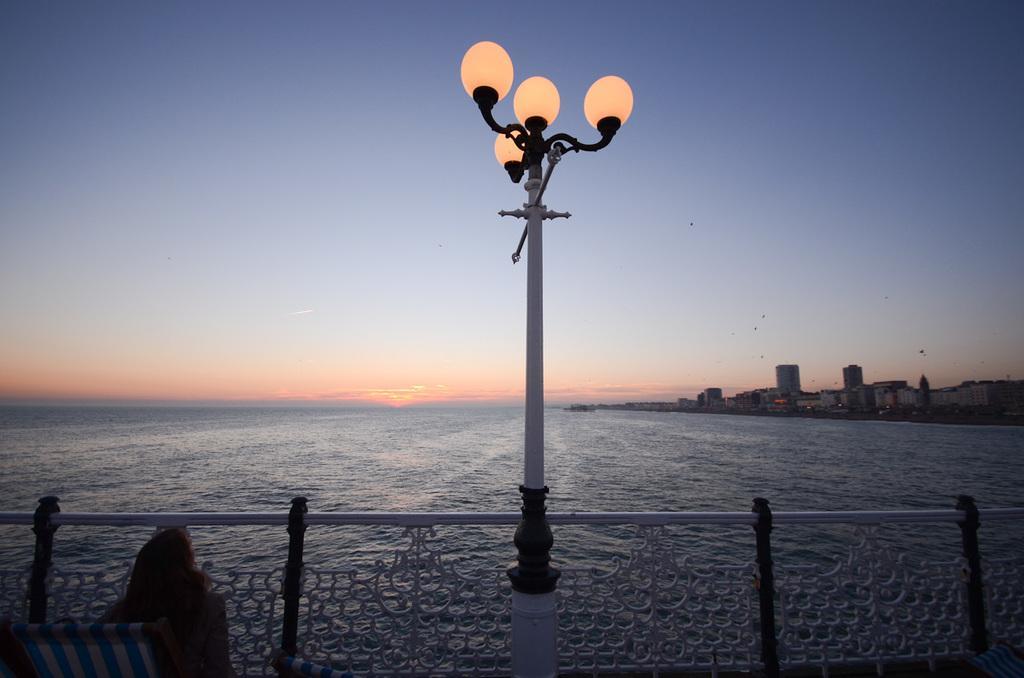In one or two sentences, can you explain what this image depicts? In this image I can see a person, background I can see a pole and few lights, water, few buildings and the sky is in blue, white and orange color. 